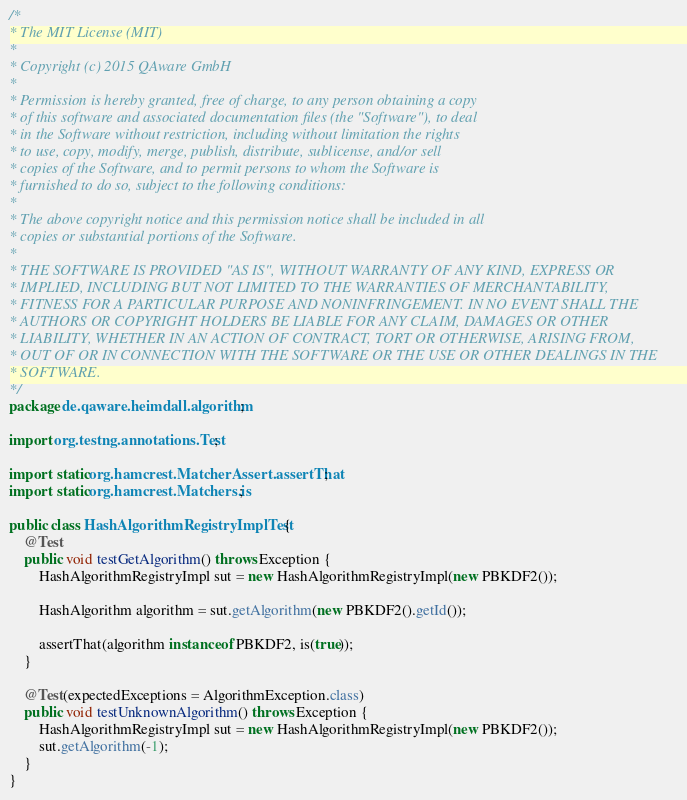Convert code to text. <code><loc_0><loc_0><loc_500><loc_500><_Java_>/*
* The MIT License (MIT)
*
* Copyright (c) 2015 QAware GmbH
*
* Permission is hereby granted, free of charge, to any person obtaining a copy
* of this software and associated documentation files (the "Software"), to deal
* in the Software without restriction, including without limitation the rights
* to use, copy, modify, merge, publish, distribute, sublicense, and/or sell
* copies of the Software, and to permit persons to whom the Software is
* furnished to do so, subject to the following conditions:
*
* The above copyright notice and this permission notice shall be included in all
* copies or substantial portions of the Software.
*
* THE SOFTWARE IS PROVIDED "AS IS", WITHOUT WARRANTY OF ANY KIND, EXPRESS OR
* IMPLIED, INCLUDING BUT NOT LIMITED TO THE WARRANTIES OF MERCHANTABILITY,
* FITNESS FOR A PARTICULAR PURPOSE AND NONINFRINGEMENT. IN NO EVENT SHALL THE
* AUTHORS OR COPYRIGHT HOLDERS BE LIABLE FOR ANY CLAIM, DAMAGES OR OTHER
* LIABILITY, WHETHER IN AN ACTION OF CONTRACT, TORT OR OTHERWISE, ARISING FROM,
* OUT OF OR IN CONNECTION WITH THE SOFTWARE OR THE USE OR OTHER DEALINGS IN THE
* SOFTWARE.
*/
package de.qaware.heimdall.algorithm;

import org.testng.annotations.Test;

import static org.hamcrest.MatcherAssert.assertThat;
import static org.hamcrest.Matchers.is;

public class HashAlgorithmRegistryImplTest {
    @Test
    public void testGetAlgorithm() throws Exception {
        HashAlgorithmRegistryImpl sut = new HashAlgorithmRegistryImpl(new PBKDF2());

        HashAlgorithm algorithm = sut.getAlgorithm(new PBKDF2().getId());

        assertThat(algorithm instanceof PBKDF2, is(true));
    }

    @Test(expectedExceptions = AlgorithmException.class)
    public void testUnknownAlgorithm() throws Exception {
        HashAlgorithmRegistryImpl sut = new HashAlgorithmRegistryImpl(new PBKDF2());
        sut.getAlgorithm(-1);
    }
}
</code> 